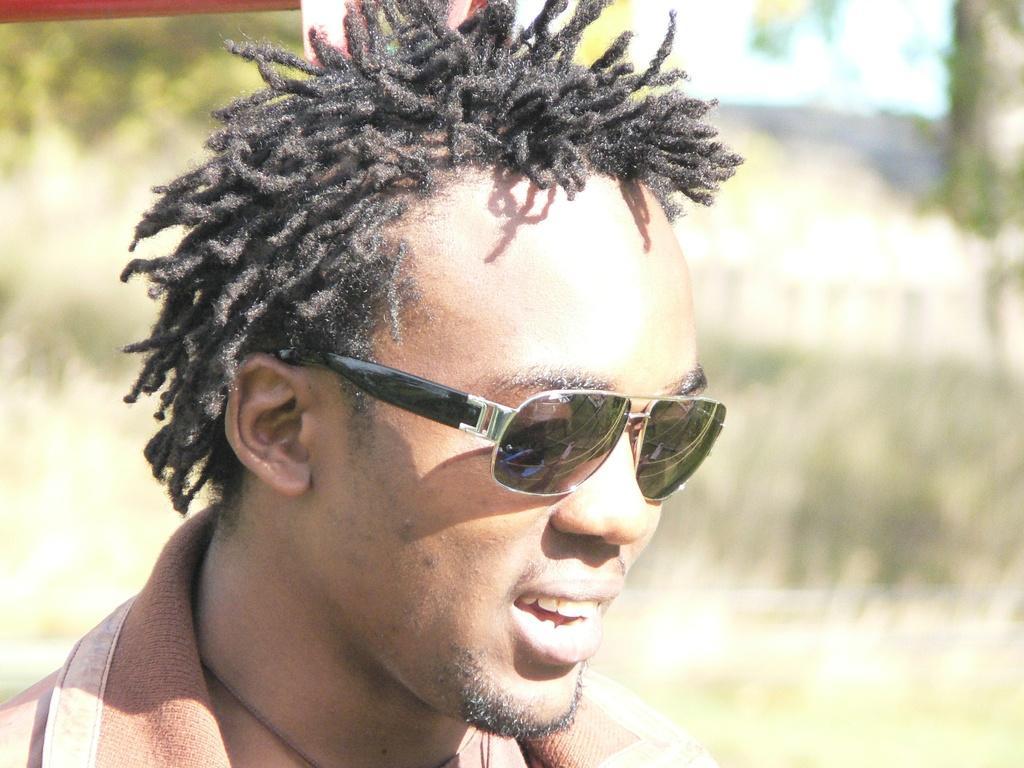How would you summarize this image in a sentence or two? In the image we can see a man wearing clothes and goggles. This man is smiling and the background is blurred. 